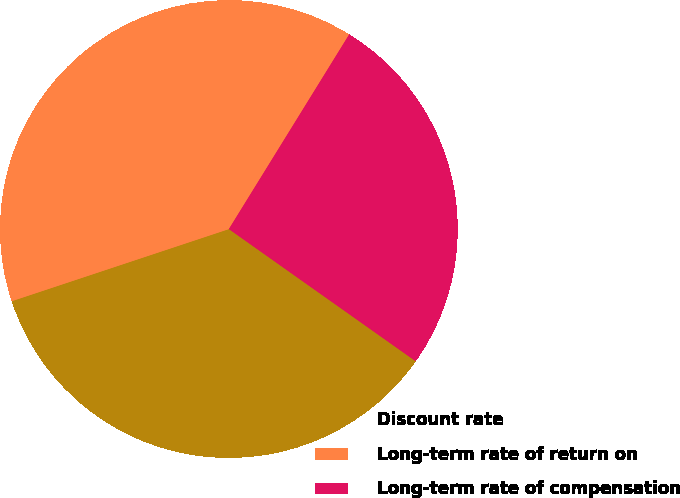Convert chart to OTSL. <chart><loc_0><loc_0><loc_500><loc_500><pie_chart><fcel>Discount rate<fcel>Long-term rate of return on<fcel>Long-term rate of compensation<nl><fcel>35.1%<fcel>38.92%<fcel>25.99%<nl></chart> 